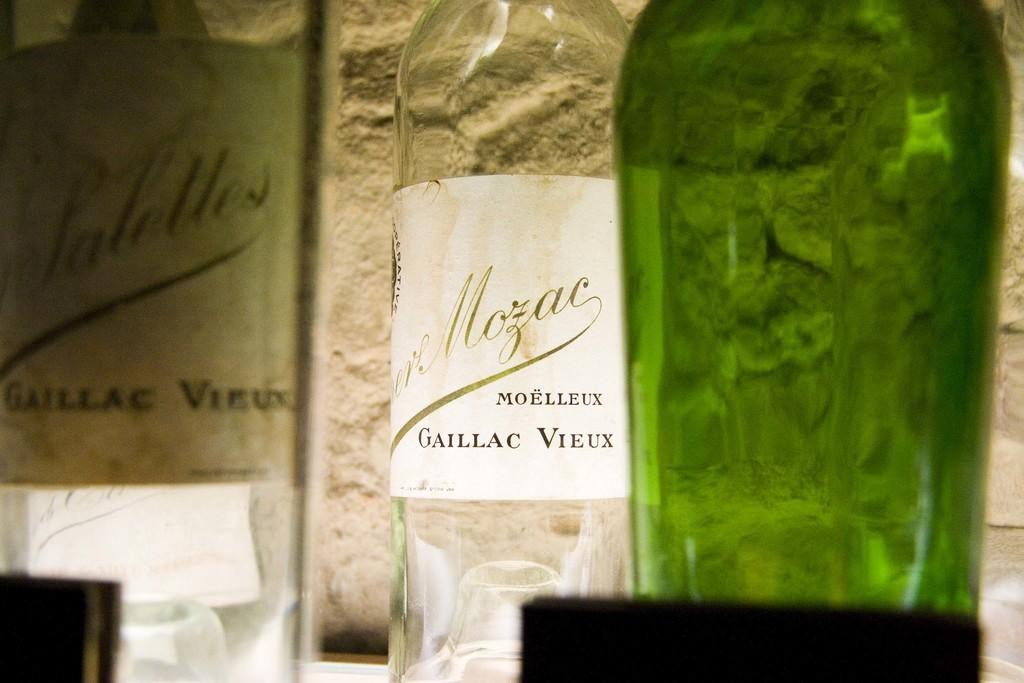Provide a one-sentence caption for the provided image. Clear wine bottle that is named "Moelleux Gaillac Vieux". 